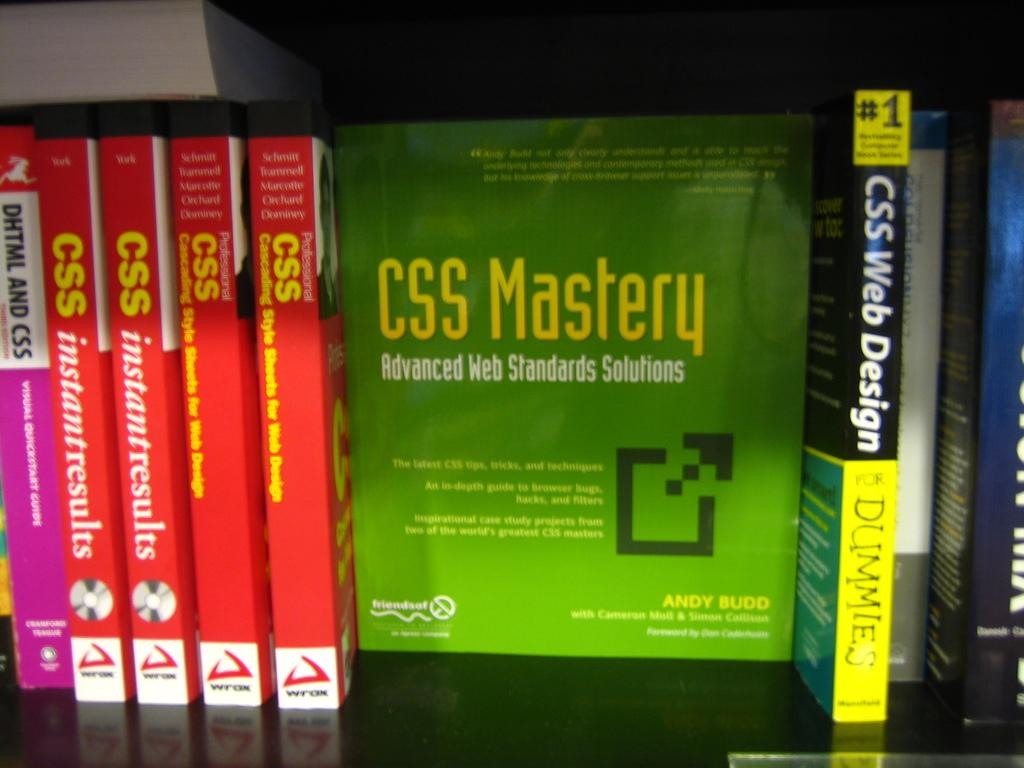Provide a one-sentence caption for the provided image. CSS training books of multiple levels are shown. 